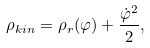Convert formula to latex. <formula><loc_0><loc_0><loc_500><loc_500>\rho _ { k i n } = \rho _ { r } ( \varphi ) + \frac { \dot { \varphi } ^ { 2 } } { 2 } ,</formula> 